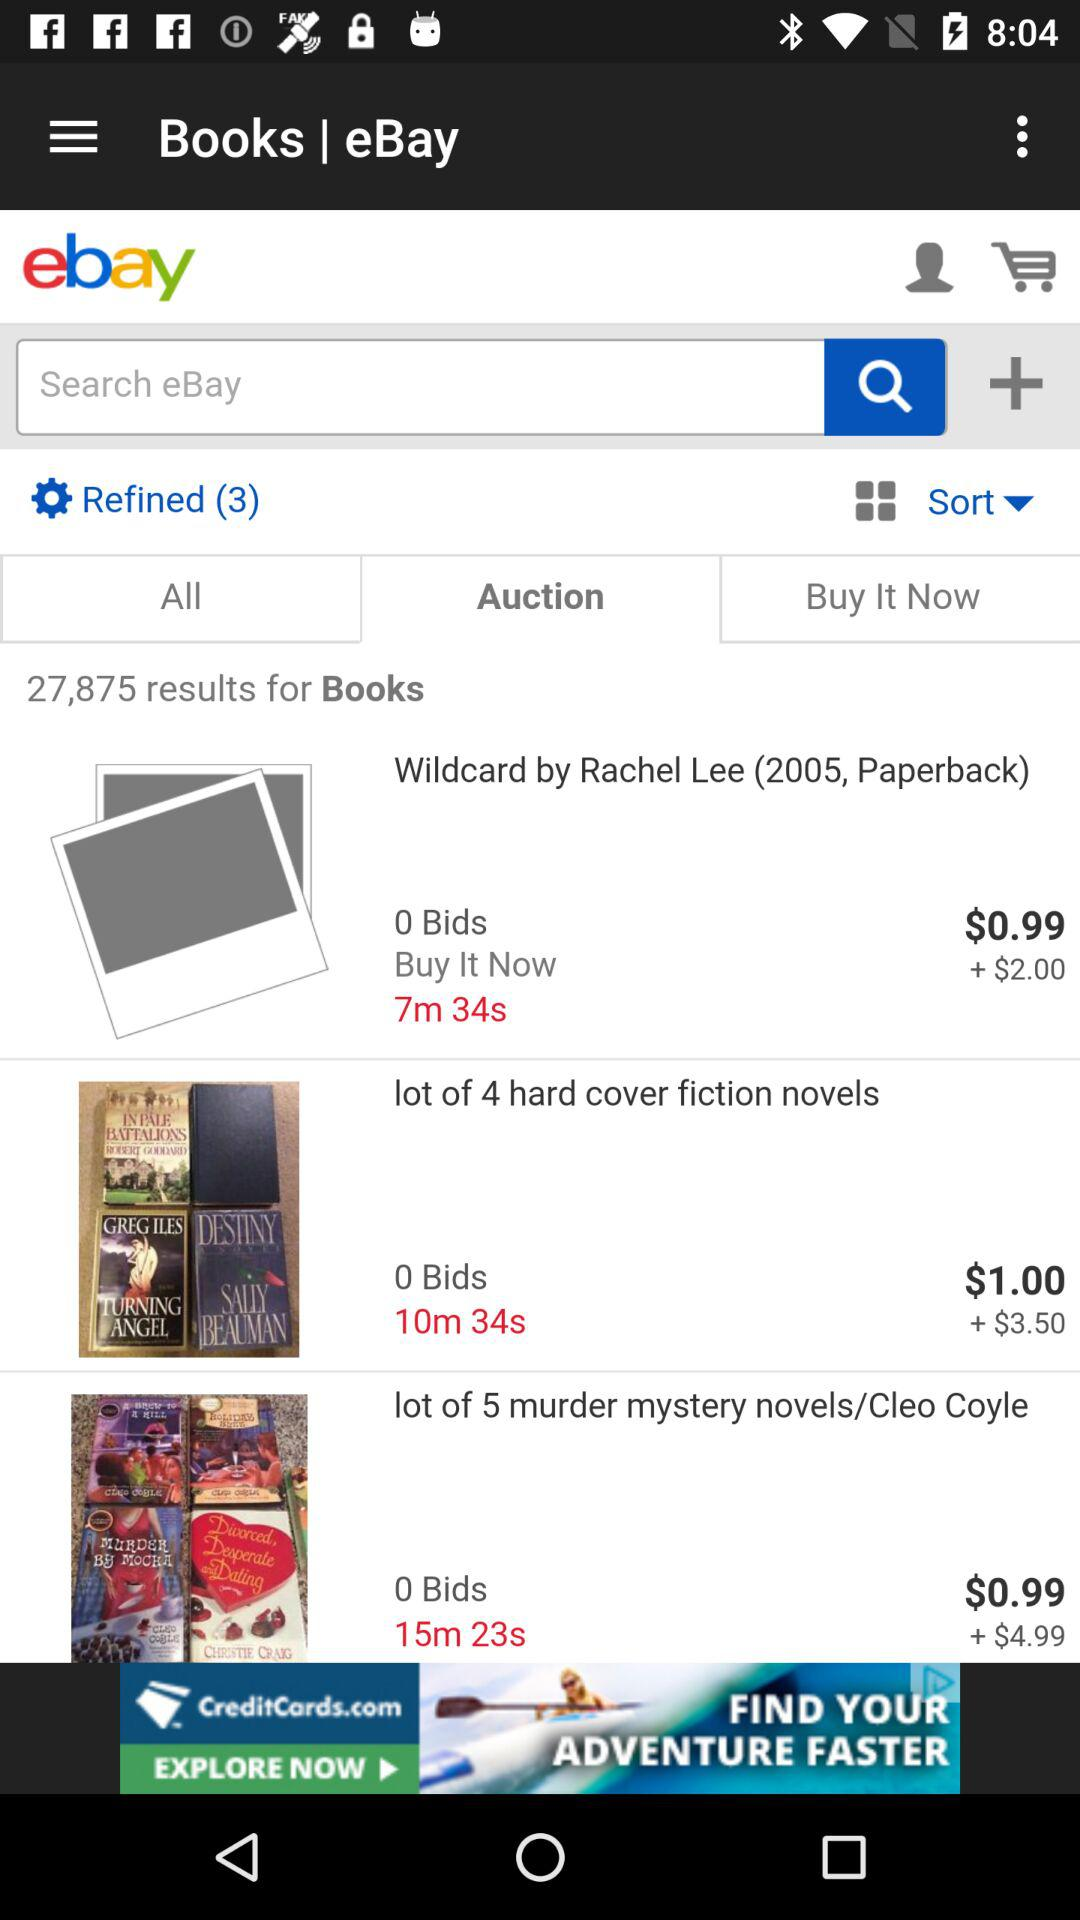What's the Buy It Now price of "Wildcard" by Rachel Lee? The Buy It Now price of "Wildcard" by Rachel Lee is $0.99. 